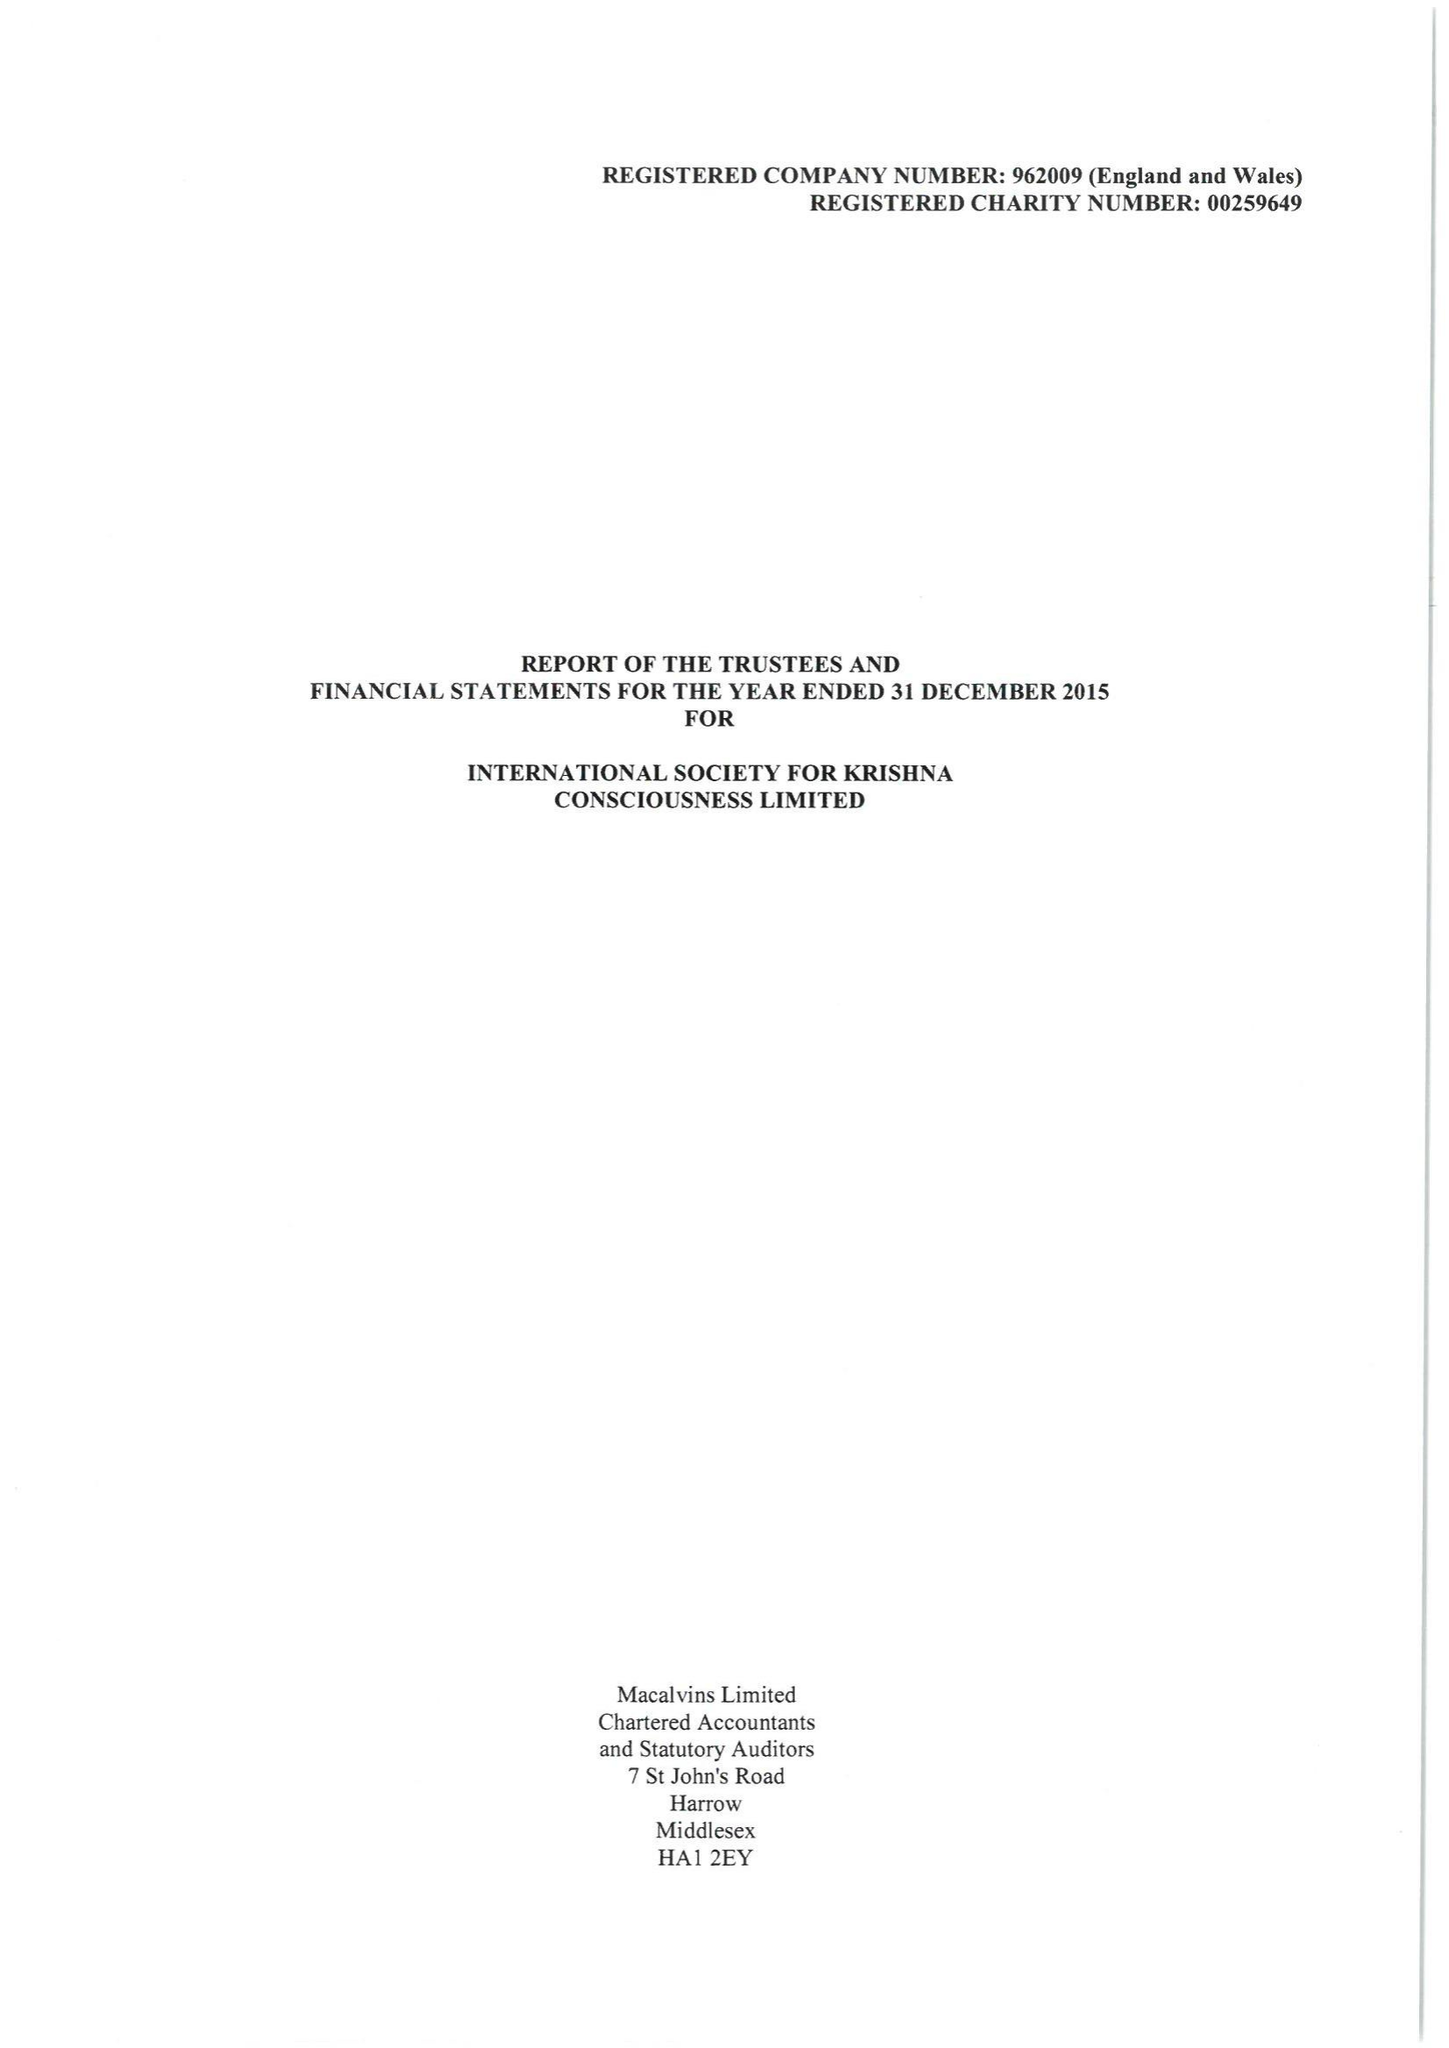What is the value for the income_annually_in_british_pounds?
Answer the question using a single word or phrase. 7370146.00 